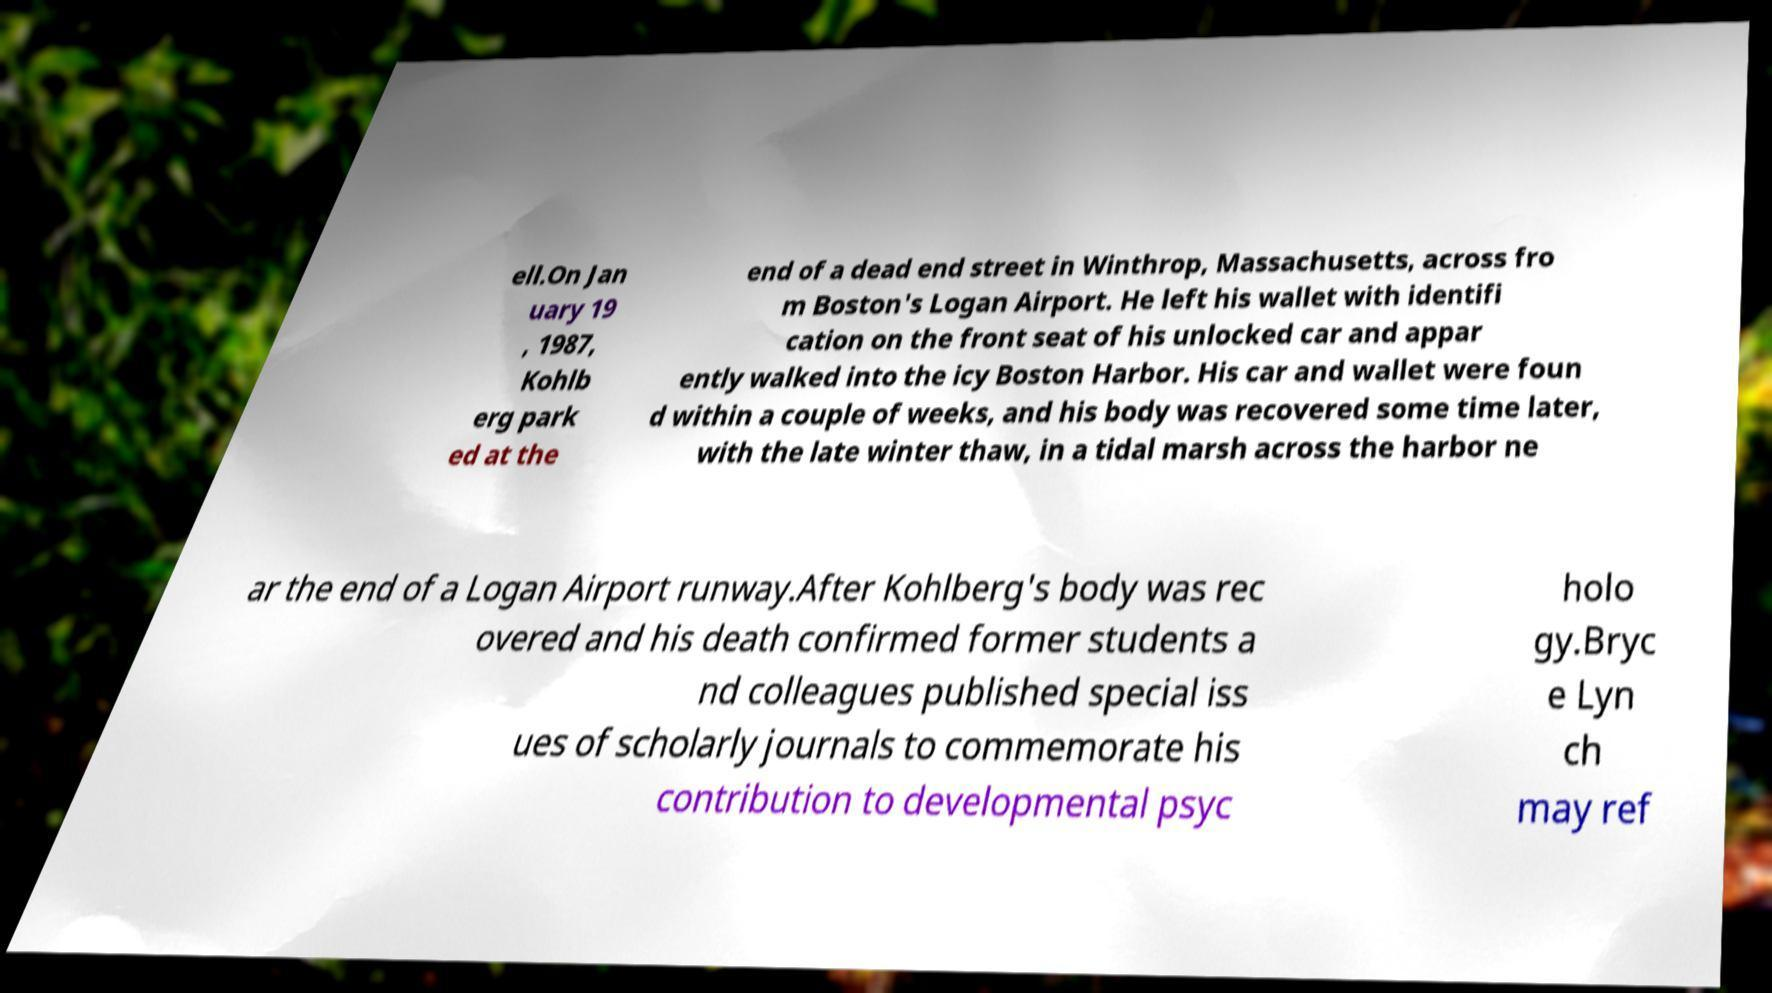There's text embedded in this image that I need extracted. Can you transcribe it verbatim? ell.On Jan uary 19 , 1987, Kohlb erg park ed at the end of a dead end street in Winthrop, Massachusetts, across fro m Boston's Logan Airport. He left his wallet with identifi cation on the front seat of his unlocked car and appar ently walked into the icy Boston Harbor. His car and wallet were foun d within a couple of weeks, and his body was recovered some time later, with the late winter thaw, in a tidal marsh across the harbor ne ar the end of a Logan Airport runway.After Kohlberg's body was rec overed and his death confirmed former students a nd colleagues published special iss ues of scholarly journals to commemorate his contribution to developmental psyc holo gy.Bryc e Lyn ch may ref 